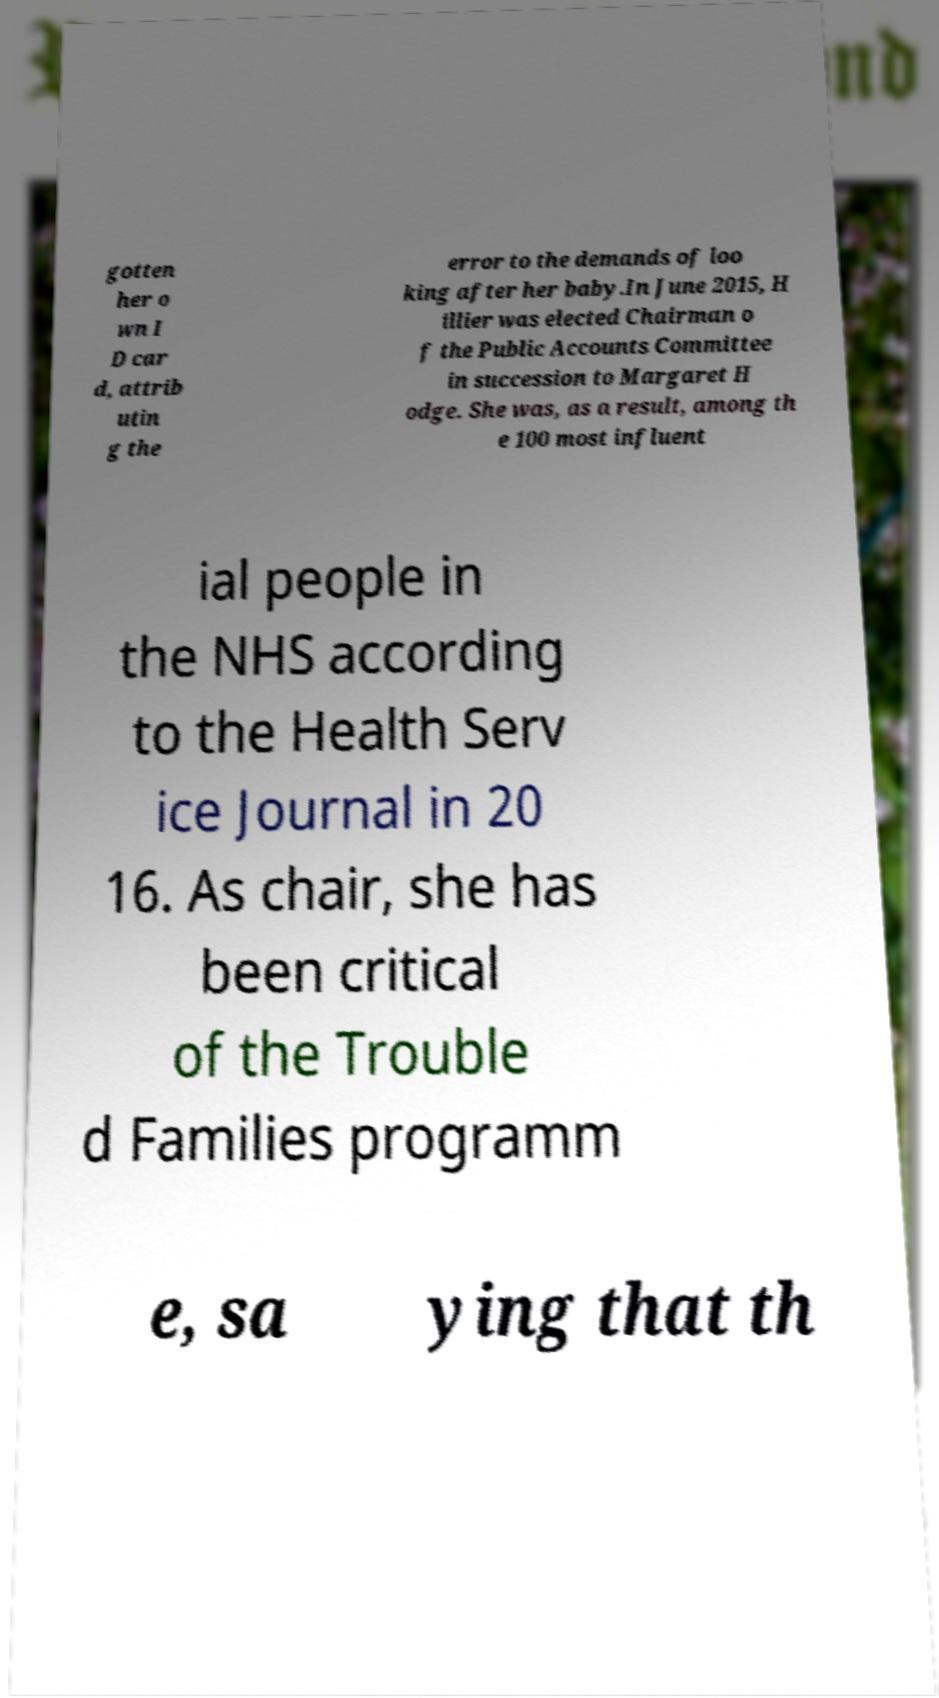There's text embedded in this image that I need extracted. Can you transcribe it verbatim? gotten her o wn I D car d, attrib utin g the error to the demands of loo king after her baby.In June 2015, H illier was elected Chairman o f the Public Accounts Committee in succession to Margaret H odge. She was, as a result, among th e 100 most influent ial people in the NHS according to the Health Serv ice Journal in 20 16. As chair, she has been critical of the Trouble d Families programm e, sa ying that th 